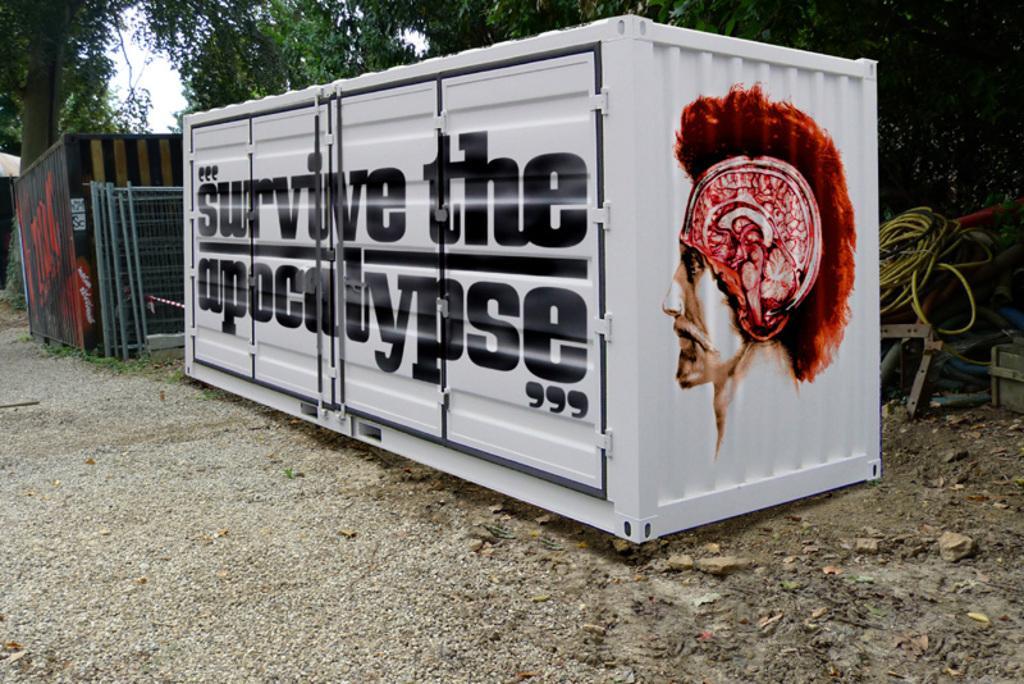Please provide a concise description of this image. In this image, we can see containers. There is a cable on the right side of the image. There are trees at the top of the image. There are metal frames on the left side of the image. 